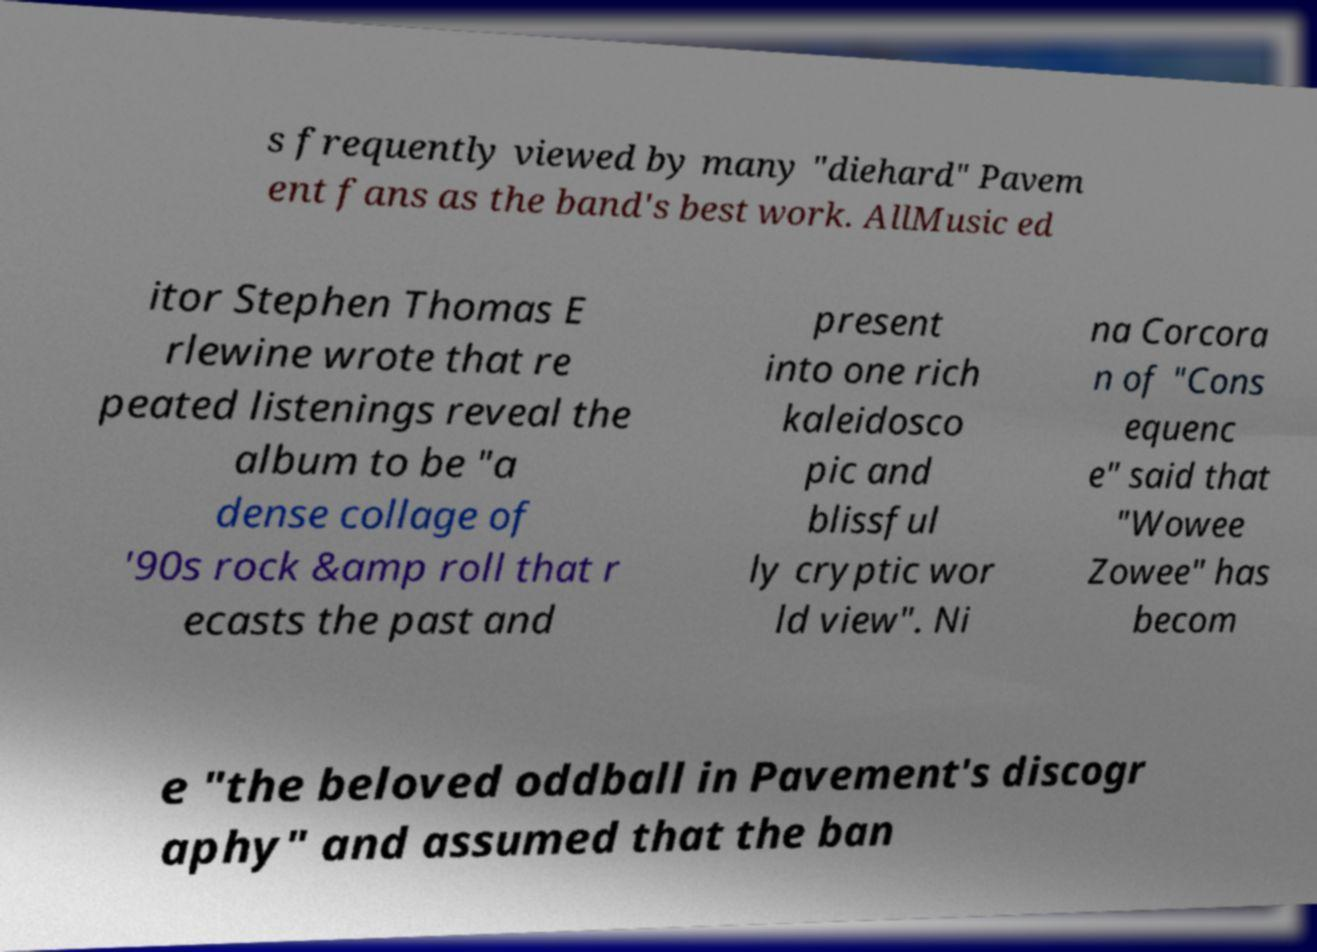Could you assist in decoding the text presented in this image and type it out clearly? s frequently viewed by many "diehard" Pavem ent fans as the band's best work. AllMusic ed itor Stephen Thomas E rlewine wrote that re peated listenings reveal the album to be "a dense collage of '90s rock &amp roll that r ecasts the past and present into one rich kaleidosco pic and blissful ly cryptic wor ld view". Ni na Corcora n of "Cons equenc e" said that "Wowee Zowee" has becom e "the beloved oddball in Pavement's discogr aphy" and assumed that the ban 